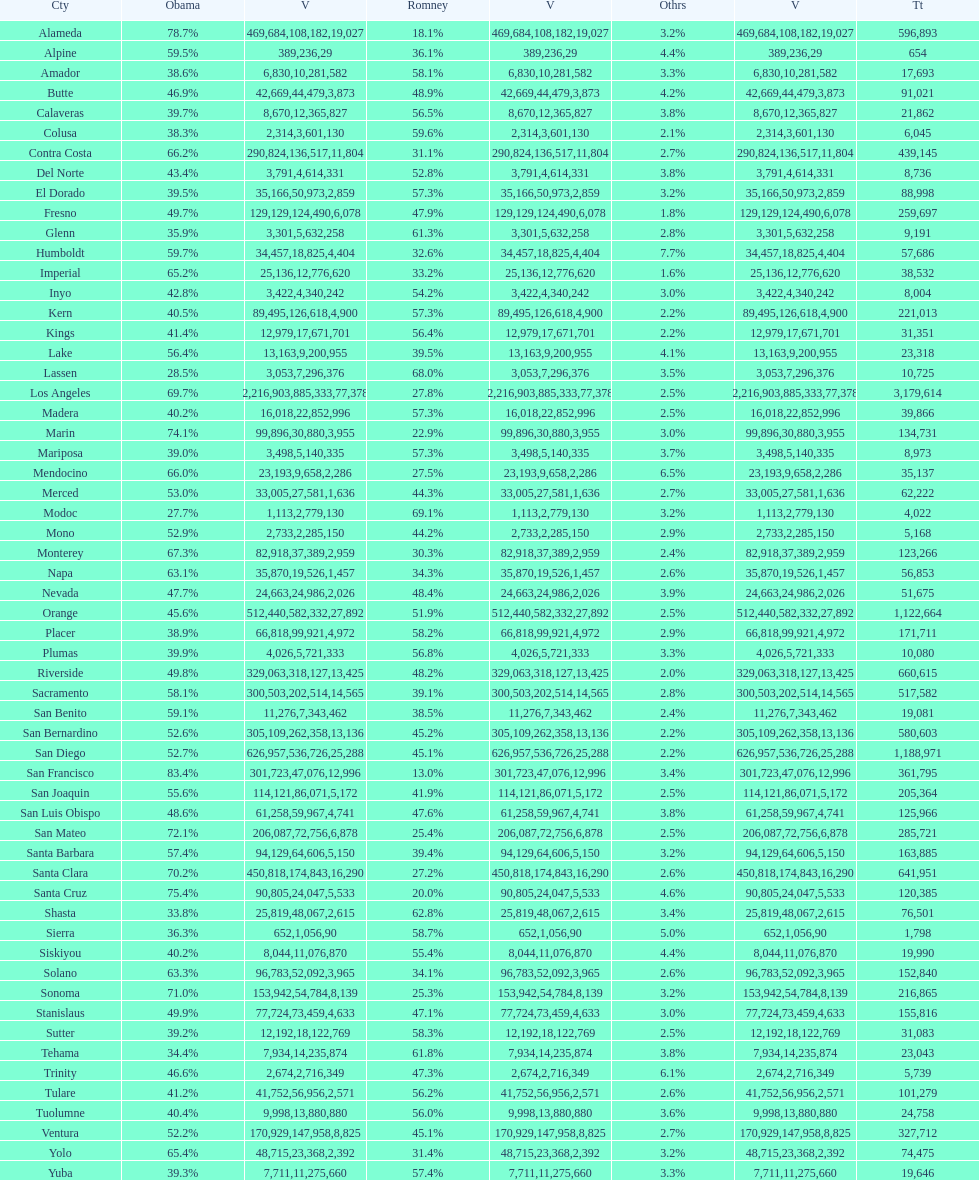What is the number of votes for obama for del norte and el dorado counties? 38957. 